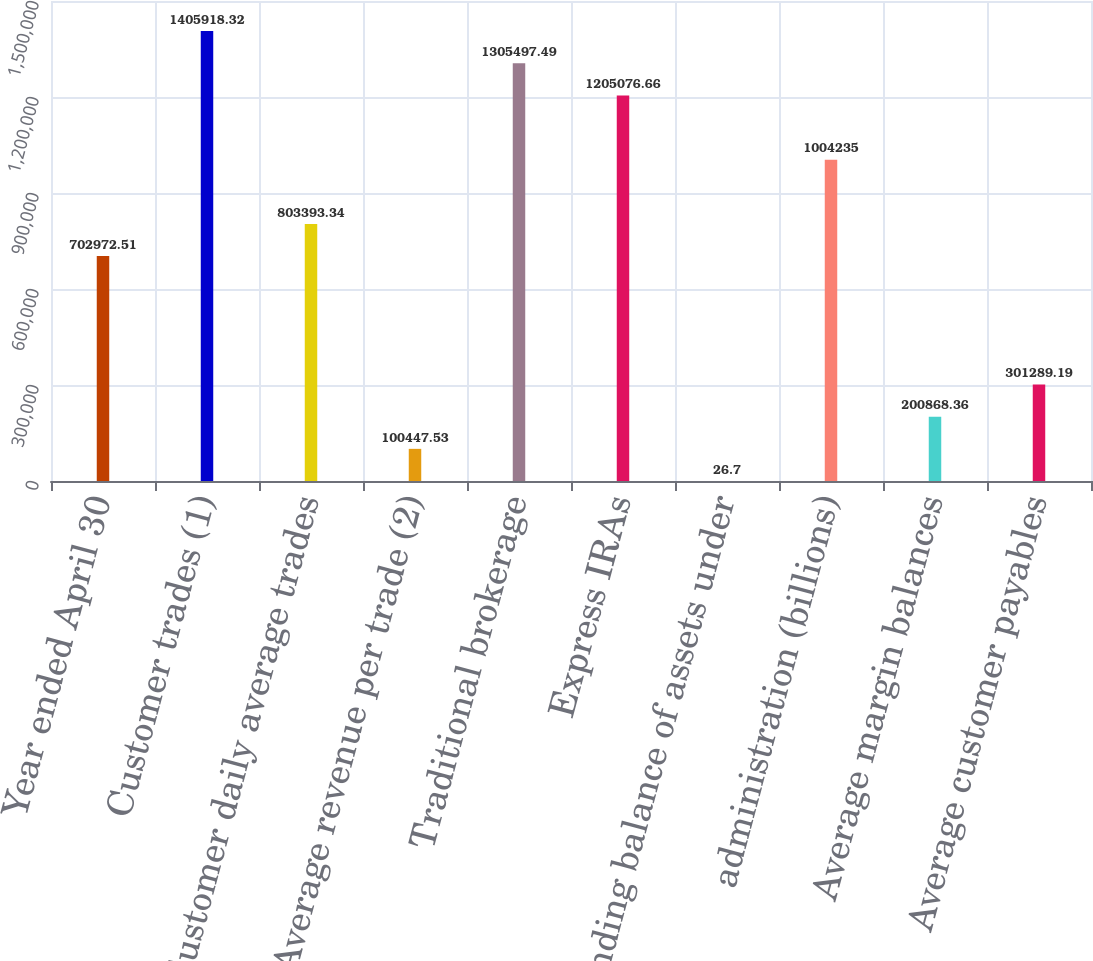Convert chart. <chart><loc_0><loc_0><loc_500><loc_500><bar_chart><fcel>Year ended April 30<fcel>Customer trades (1)<fcel>Customer daily average trades<fcel>Average revenue per trade (2)<fcel>Traditional brokerage<fcel>Express IRAs<fcel>Ending balance of assets under<fcel>administration (billions)<fcel>Average margin balances<fcel>Average customer payables<nl><fcel>702973<fcel>1.40592e+06<fcel>803393<fcel>100448<fcel>1.3055e+06<fcel>1.20508e+06<fcel>26.7<fcel>1.00424e+06<fcel>200868<fcel>301289<nl></chart> 